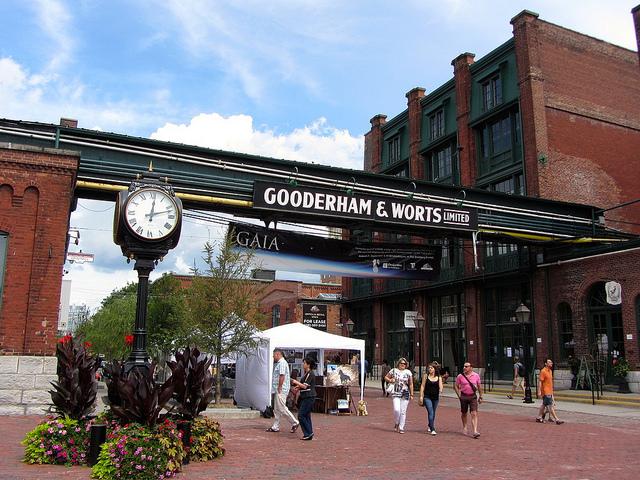How many females are in this picture?
Quick response, please. 3. How many bricks did it take to make the buildings?
Quick response, please. Thousands. What time is the clock displaying?
Concise answer only. 12:12. 